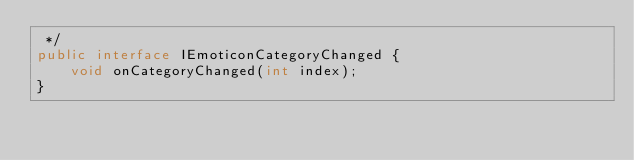<code> <loc_0><loc_0><loc_500><loc_500><_Java_> */
public interface IEmoticonCategoryChanged {
    void onCategoryChanged(int index);
}
</code> 